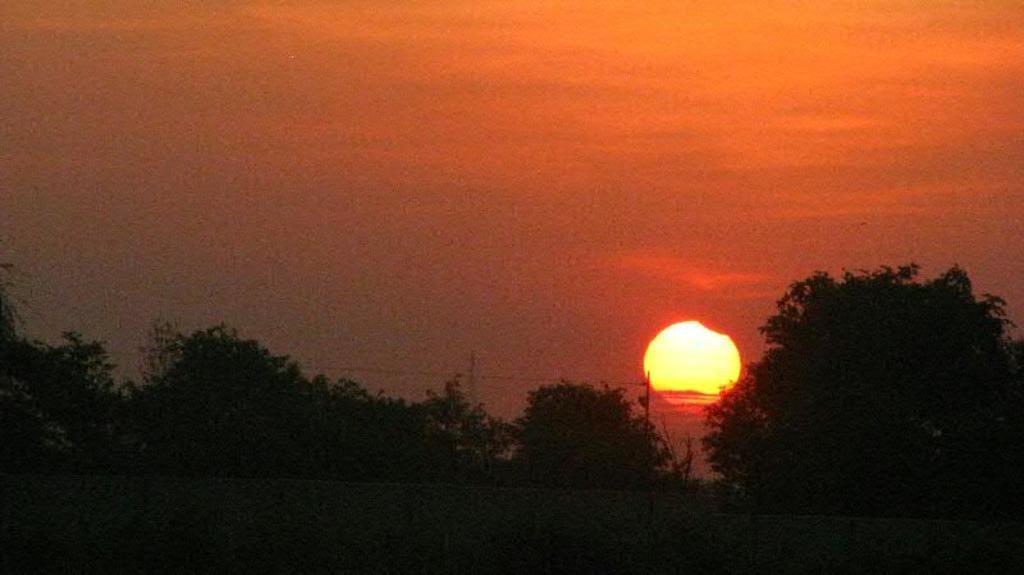Please provide a concise description of this image. In this image I can see trees. In the background I can see the sun and the sky. 